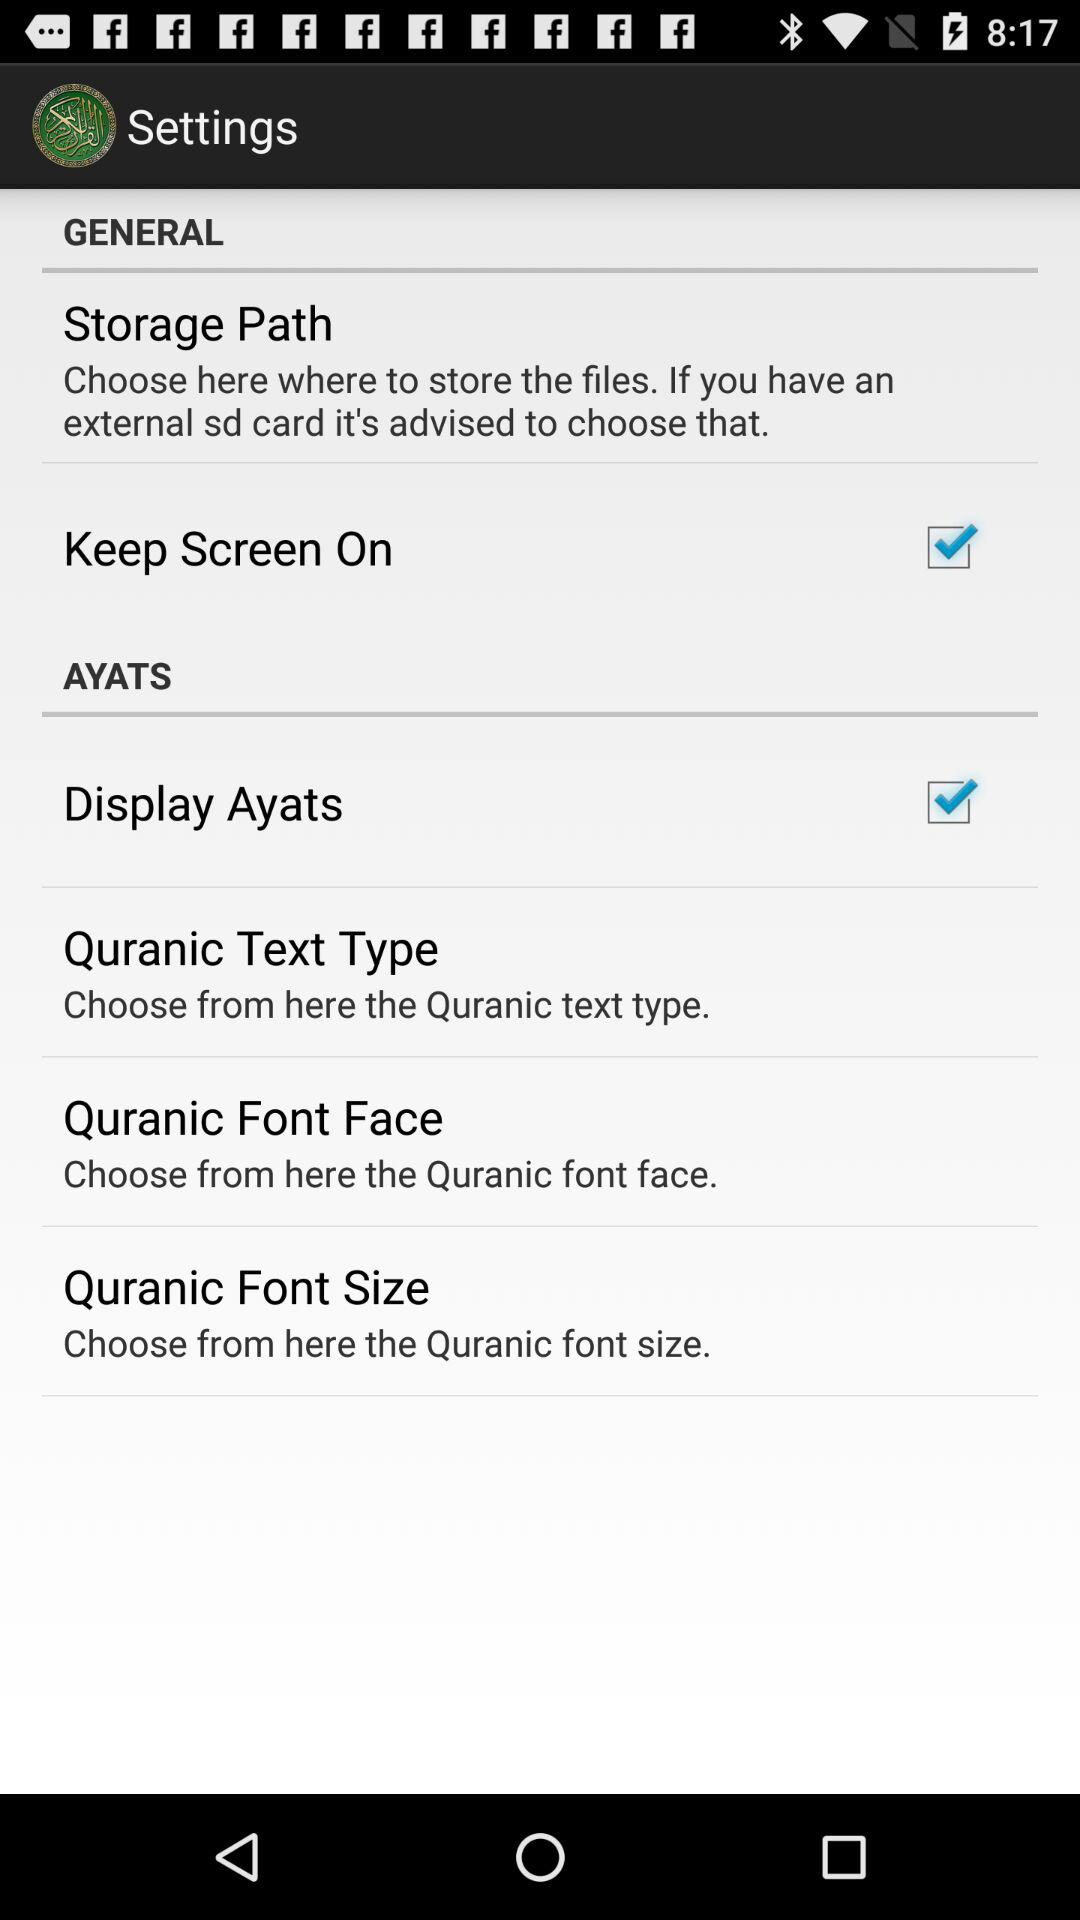What is the status of "Keep Screen On"? The status of "Keep Screen On" is "on". 